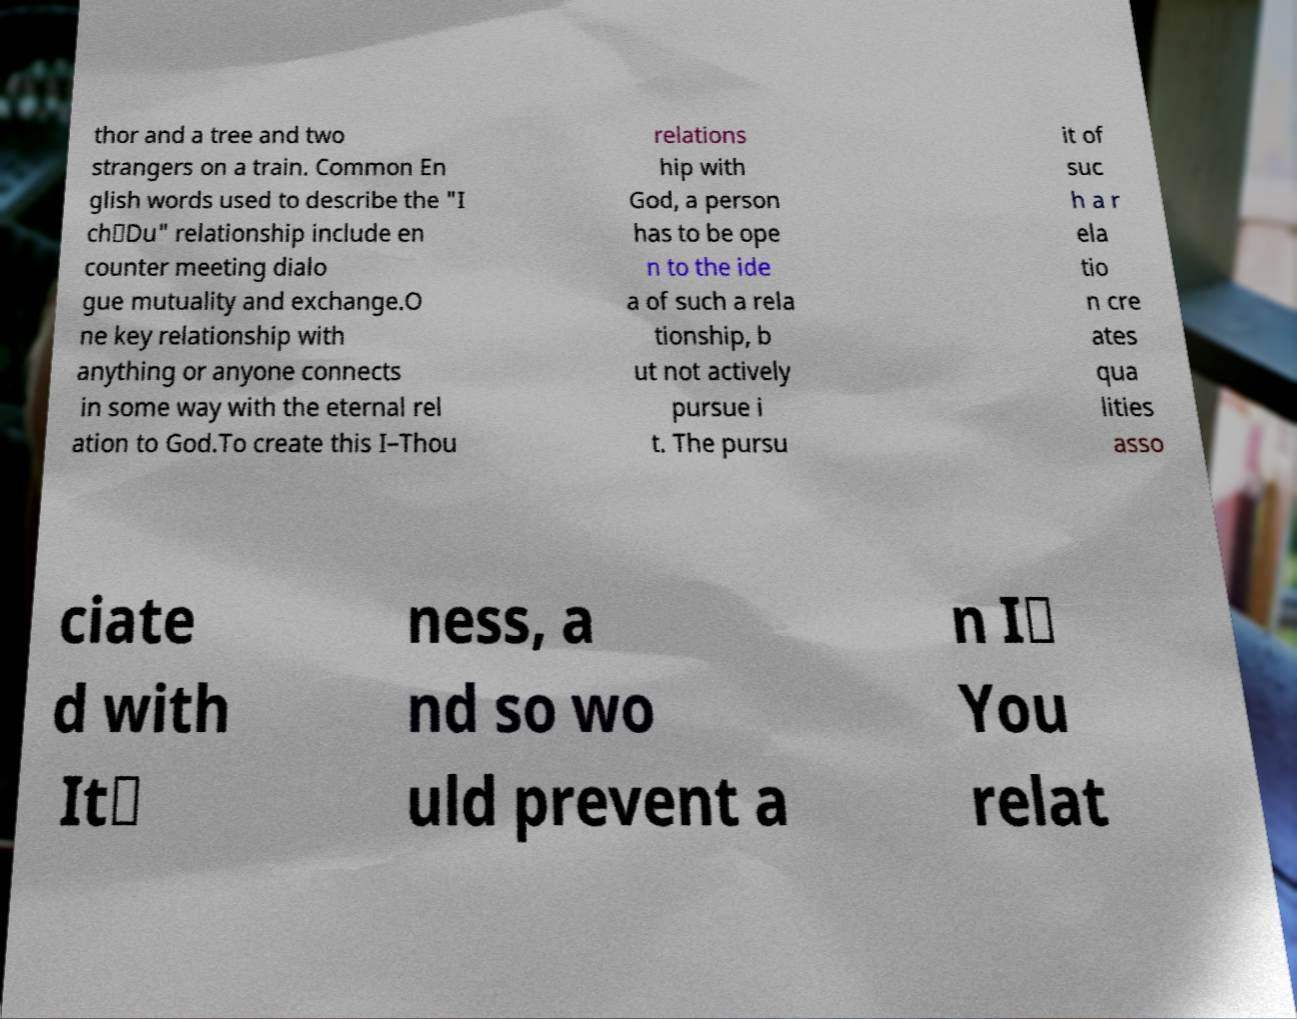I need the written content from this picture converted into text. Can you do that? thor and a tree and two strangers on a train. Common En glish words used to describe the "I ch‑Du" relationship include en counter meeting dialo gue mutuality and exchange.O ne key relationship with anything or anyone connects in some way with the eternal rel ation to God.To create this I–Thou relations hip with God, a person has to be ope n to the ide a of such a rela tionship, b ut not actively pursue i t. The pursu it of suc h a r ela tio n cre ates qua lities asso ciate d with It‑ ness, a nd so wo uld prevent a n I‑ You relat 